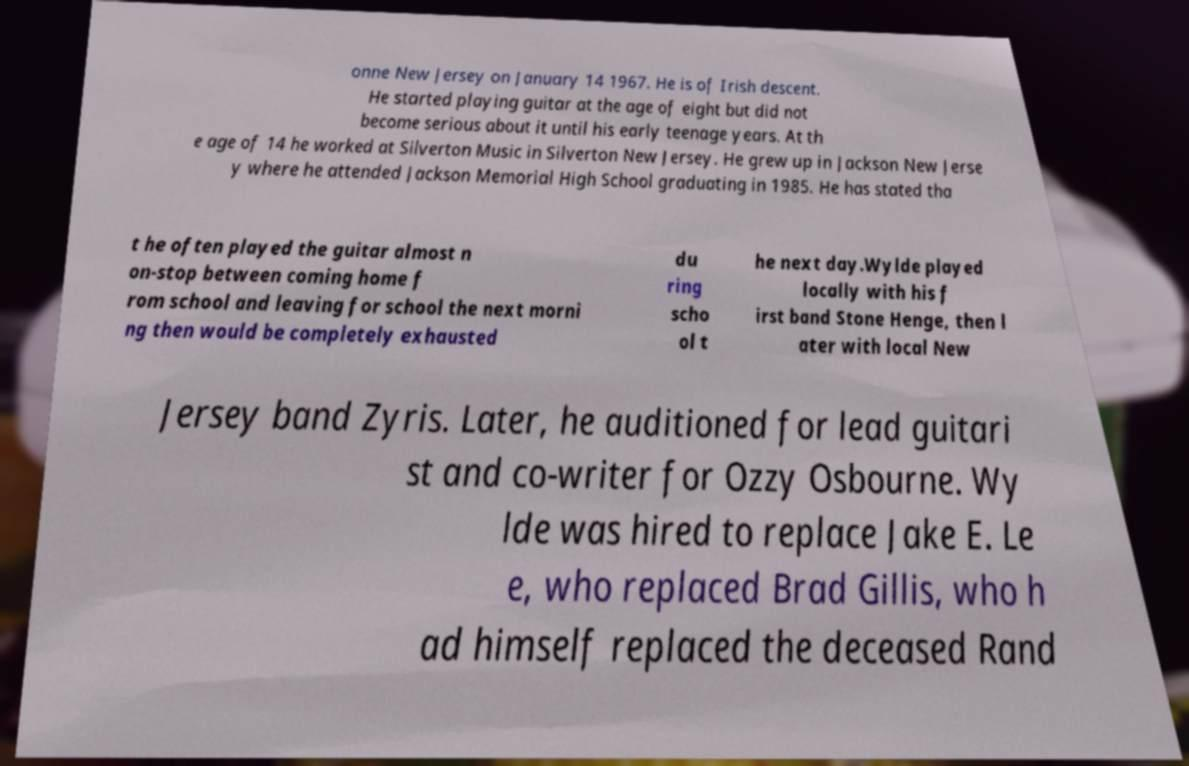Could you extract and type out the text from this image? onne New Jersey on January 14 1967. He is of Irish descent. He started playing guitar at the age of eight but did not become serious about it until his early teenage years. At th e age of 14 he worked at Silverton Music in Silverton New Jersey. He grew up in Jackson New Jerse y where he attended Jackson Memorial High School graduating in 1985. He has stated tha t he often played the guitar almost n on-stop between coming home f rom school and leaving for school the next morni ng then would be completely exhausted du ring scho ol t he next day.Wylde played locally with his f irst band Stone Henge, then l ater with local New Jersey band Zyris. Later, he auditioned for lead guitari st and co-writer for Ozzy Osbourne. Wy lde was hired to replace Jake E. Le e, who replaced Brad Gillis, who h ad himself replaced the deceased Rand 